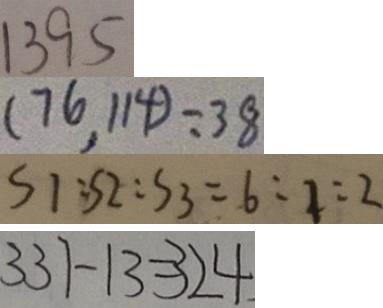<formula> <loc_0><loc_0><loc_500><loc_500>1 3 9 5 
 ( 7 6 , 1 1 4 ) = 3 8 
 S 1 : S 2 : S 3 = 6 : 1 : 2 
 3 3 7 - 1 3 = 3 2 4</formula> 